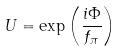<formula> <loc_0><loc_0><loc_500><loc_500>U = \exp \left ( \frac { i \Phi } { f _ { \pi } } \right )</formula> 